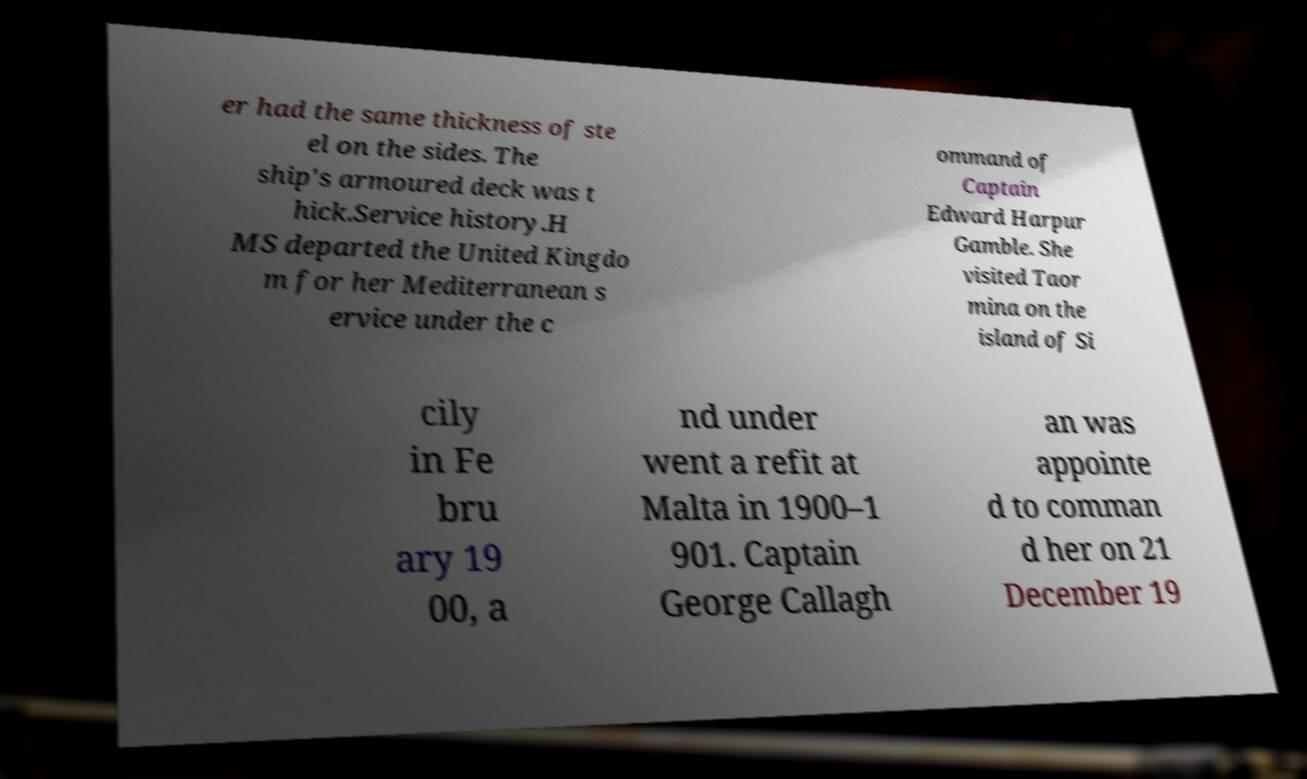Can you accurately transcribe the text from the provided image for me? er had the same thickness of ste el on the sides. The ship's armoured deck was t hick.Service history.H MS departed the United Kingdo m for her Mediterranean s ervice under the c ommand of Captain Edward Harpur Gamble. She visited Taor mina on the island of Si cily in Fe bru ary 19 00, a nd under went a refit at Malta in 1900–1 901. Captain George Callagh an was appointe d to comman d her on 21 December 19 